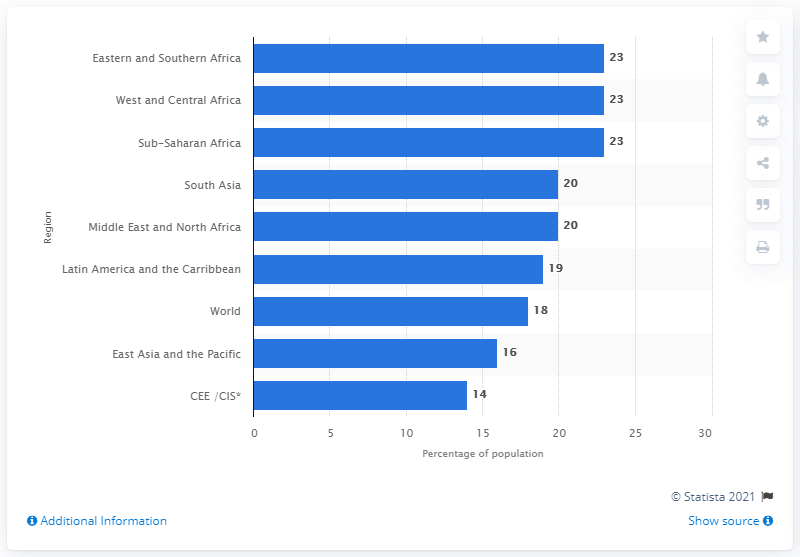Specify some key components in this picture. Approximately 23% of Sub-Saharan Africa's population is between the ages of 10 and 19. 